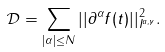Convert formula to latex. <formula><loc_0><loc_0><loc_500><loc_500>\mathcal { D } = \sum _ { | \alpha | \leq N } | | \partial ^ { \alpha } f ( t ) | | ^ { 2 } _ { I ^ { a , \gamma } } .</formula> 